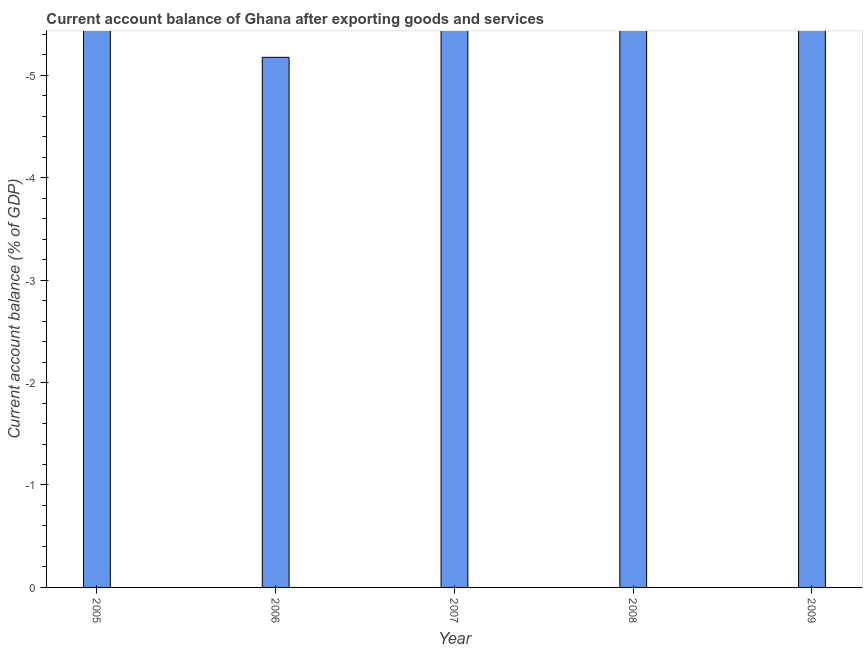Does the graph contain any zero values?
Offer a terse response. Yes. What is the title of the graph?
Provide a succinct answer. Current account balance of Ghana after exporting goods and services. What is the label or title of the Y-axis?
Ensure brevity in your answer.  Current account balance (% of GDP). Across all years, what is the minimum current account balance?
Give a very brief answer. 0. What is the sum of the current account balance?
Offer a very short reply. 0. What is the median current account balance?
Your answer should be compact. 0. How many bars are there?
Offer a terse response. 0. Are all the bars in the graph horizontal?
Your answer should be compact. No. How many years are there in the graph?
Make the answer very short. 5. What is the Current account balance (% of GDP) of 2005?
Offer a very short reply. 0. What is the Current account balance (% of GDP) of 2006?
Your response must be concise. 0. What is the Current account balance (% of GDP) in 2008?
Provide a succinct answer. 0. What is the Current account balance (% of GDP) in 2009?
Give a very brief answer. 0. 